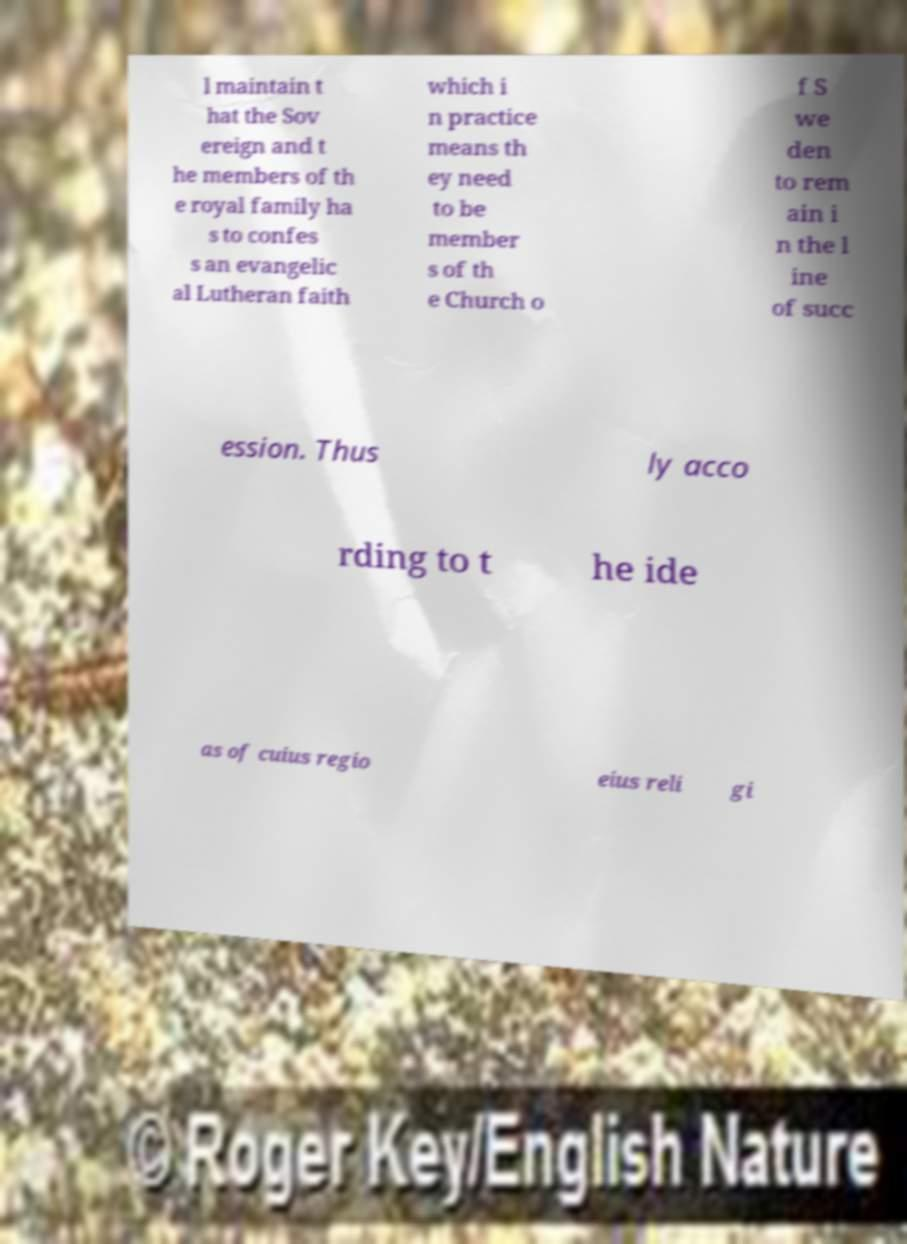For documentation purposes, I need the text within this image transcribed. Could you provide that? l maintain t hat the Sov ereign and t he members of th e royal family ha s to confes s an evangelic al Lutheran faith which i n practice means th ey need to be member s of th e Church o f S we den to rem ain i n the l ine of succ ession. Thus ly acco rding to t he ide as of cuius regio eius reli gi 